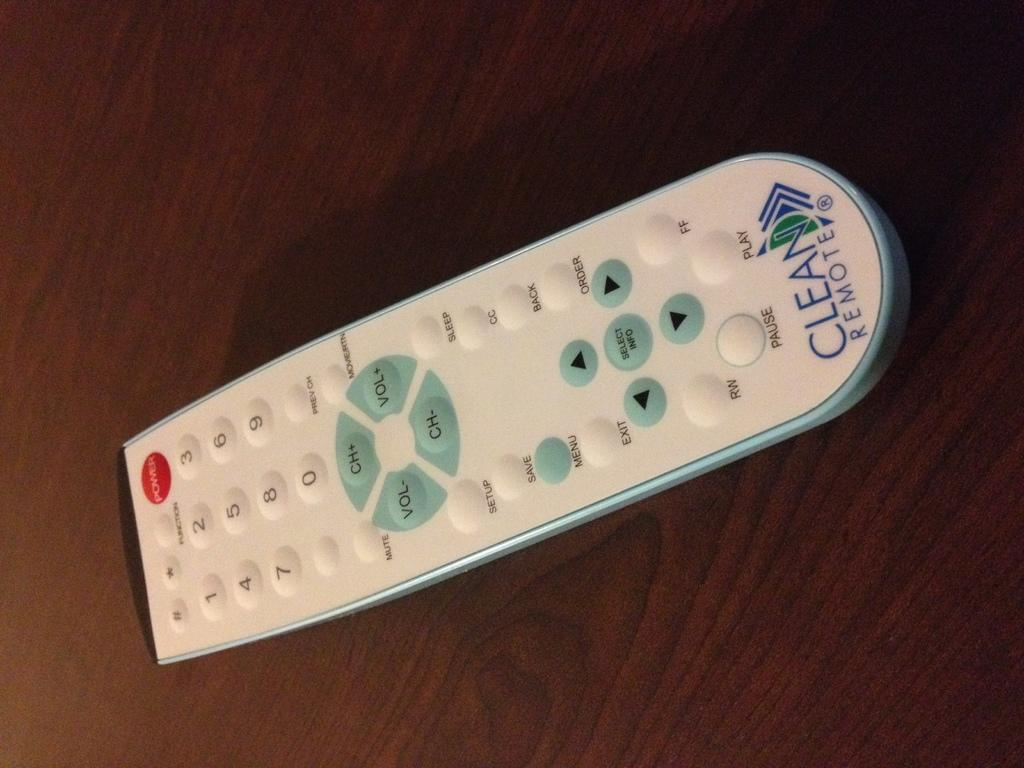<image>
Relay a brief, clear account of the picture shown. The Clean Remote is mostly white in color. 